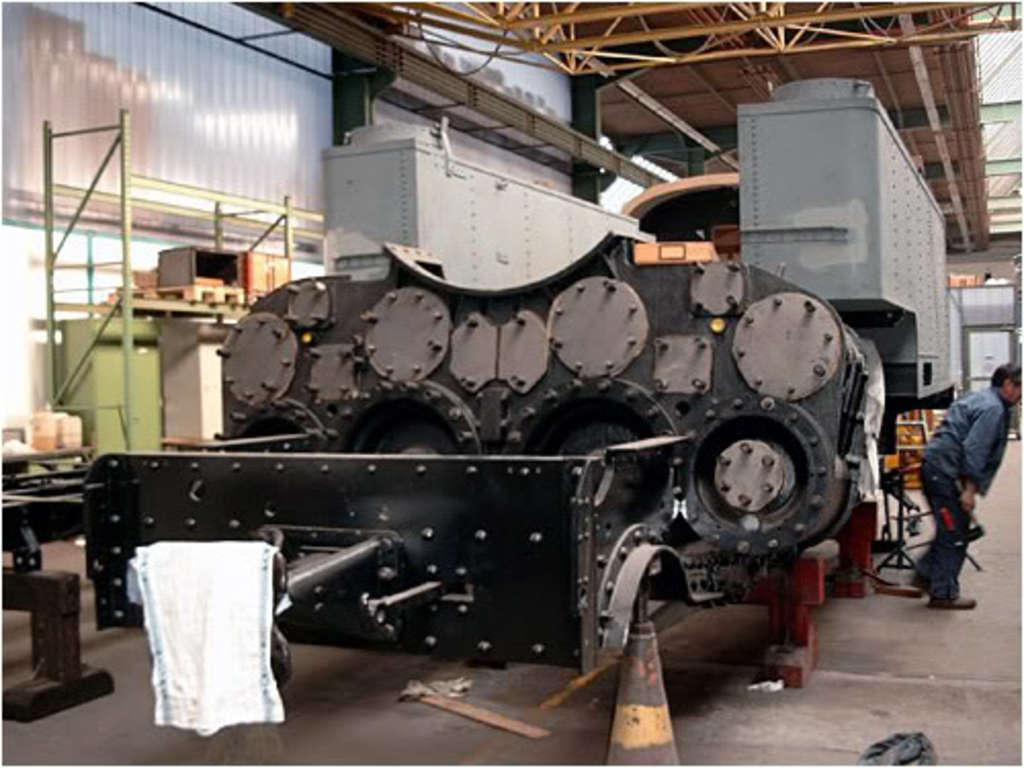What type of vehicle is represented by the iron part in the image? The image shows an iron part of a big vehicle, but it does not specify the type of vehicle. What structure can be seen at the top of the image? There is a shed at the top of the image. Where is the man located in the image? The man is on the right side of the image. What type of pest can be seen in the bedroom in the image? There is no bedroom or pest present in the image. How does the man blow air in the image? There is no indication of the man blowing air in the image. 